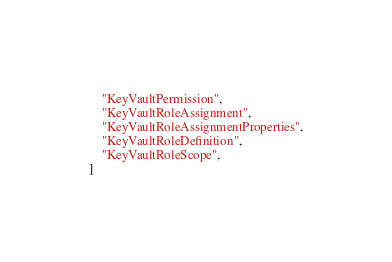<code> <loc_0><loc_0><loc_500><loc_500><_Python_>    "KeyVaultPermission",
    "KeyVaultRoleAssignment",
    "KeyVaultRoleAssignmentProperties",
    "KeyVaultRoleDefinition",
    "KeyVaultRoleScope",
]
</code> 